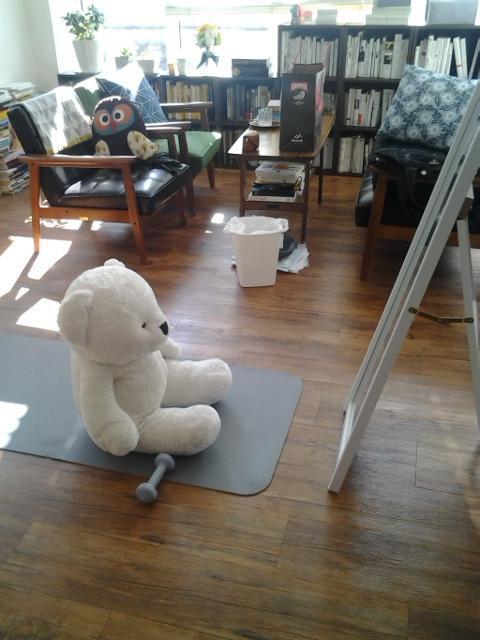How many stuffed animals are in the room?
Give a very brief answer. 2. How many chairs are in the picture?
Give a very brief answer. 3. 